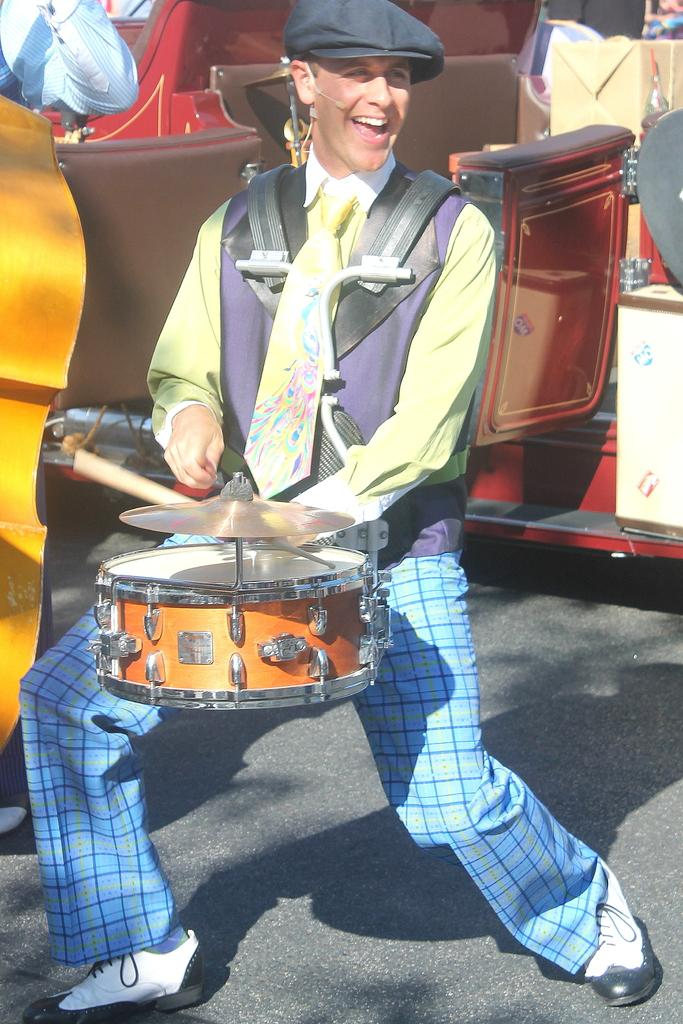What is the man in the image doing? The man is playing a musical instrument in the image. What can be seen in the background of the image? There is a vehicle and a box in the background of the image. Where is the musical instrument located on the left side of the image? The musical instrument is on the left side of the image. Whose hand is visible in the image? A person's hand is visible in the image. How does the man show respect to the island in the image? There is no island present in the image, and therefore no opportunity for the man to show respect to it. 